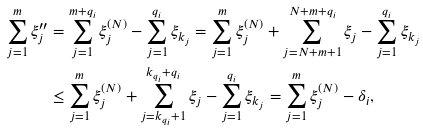Convert formula to latex. <formula><loc_0><loc_0><loc_500><loc_500>\sum _ { j = 1 } ^ { m } \xi ^ { \prime \prime } _ { j } & = \sum _ { j = 1 } ^ { m + q _ { i } } \xi ^ { ( N ) } _ { j } - \sum _ { j = 1 } ^ { q _ { i } } \xi _ { k _ { j } } = \sum _ { j = 1 } ^ { m } \xi ^ { ( N ) } _ { j } + \sum _ { j = N + m + 1 } ^ { N + m + q _ { i } } \xi _ { j } - \sum _ { j = 1 } ^ { q _ { i } } \xi _ { k _ { j } } \\ & \leq \sum _ { j = 1 } ^ { m } \xi ^ { ( N ) } _ { j } + \sum _ { j = k _ { q _ { i } } + 1 } ^ { k _ { q _ { i } } + q _ { i } } \xi _ { j } - \sum _ { j = 1 } ^ { q _ { i } } \xi _ { k _ { j } } = \sum _ { j = 1 } ^ { m } \xi ^ { ( N ) } _ { j } - \delta _ { i } ,</formula> 